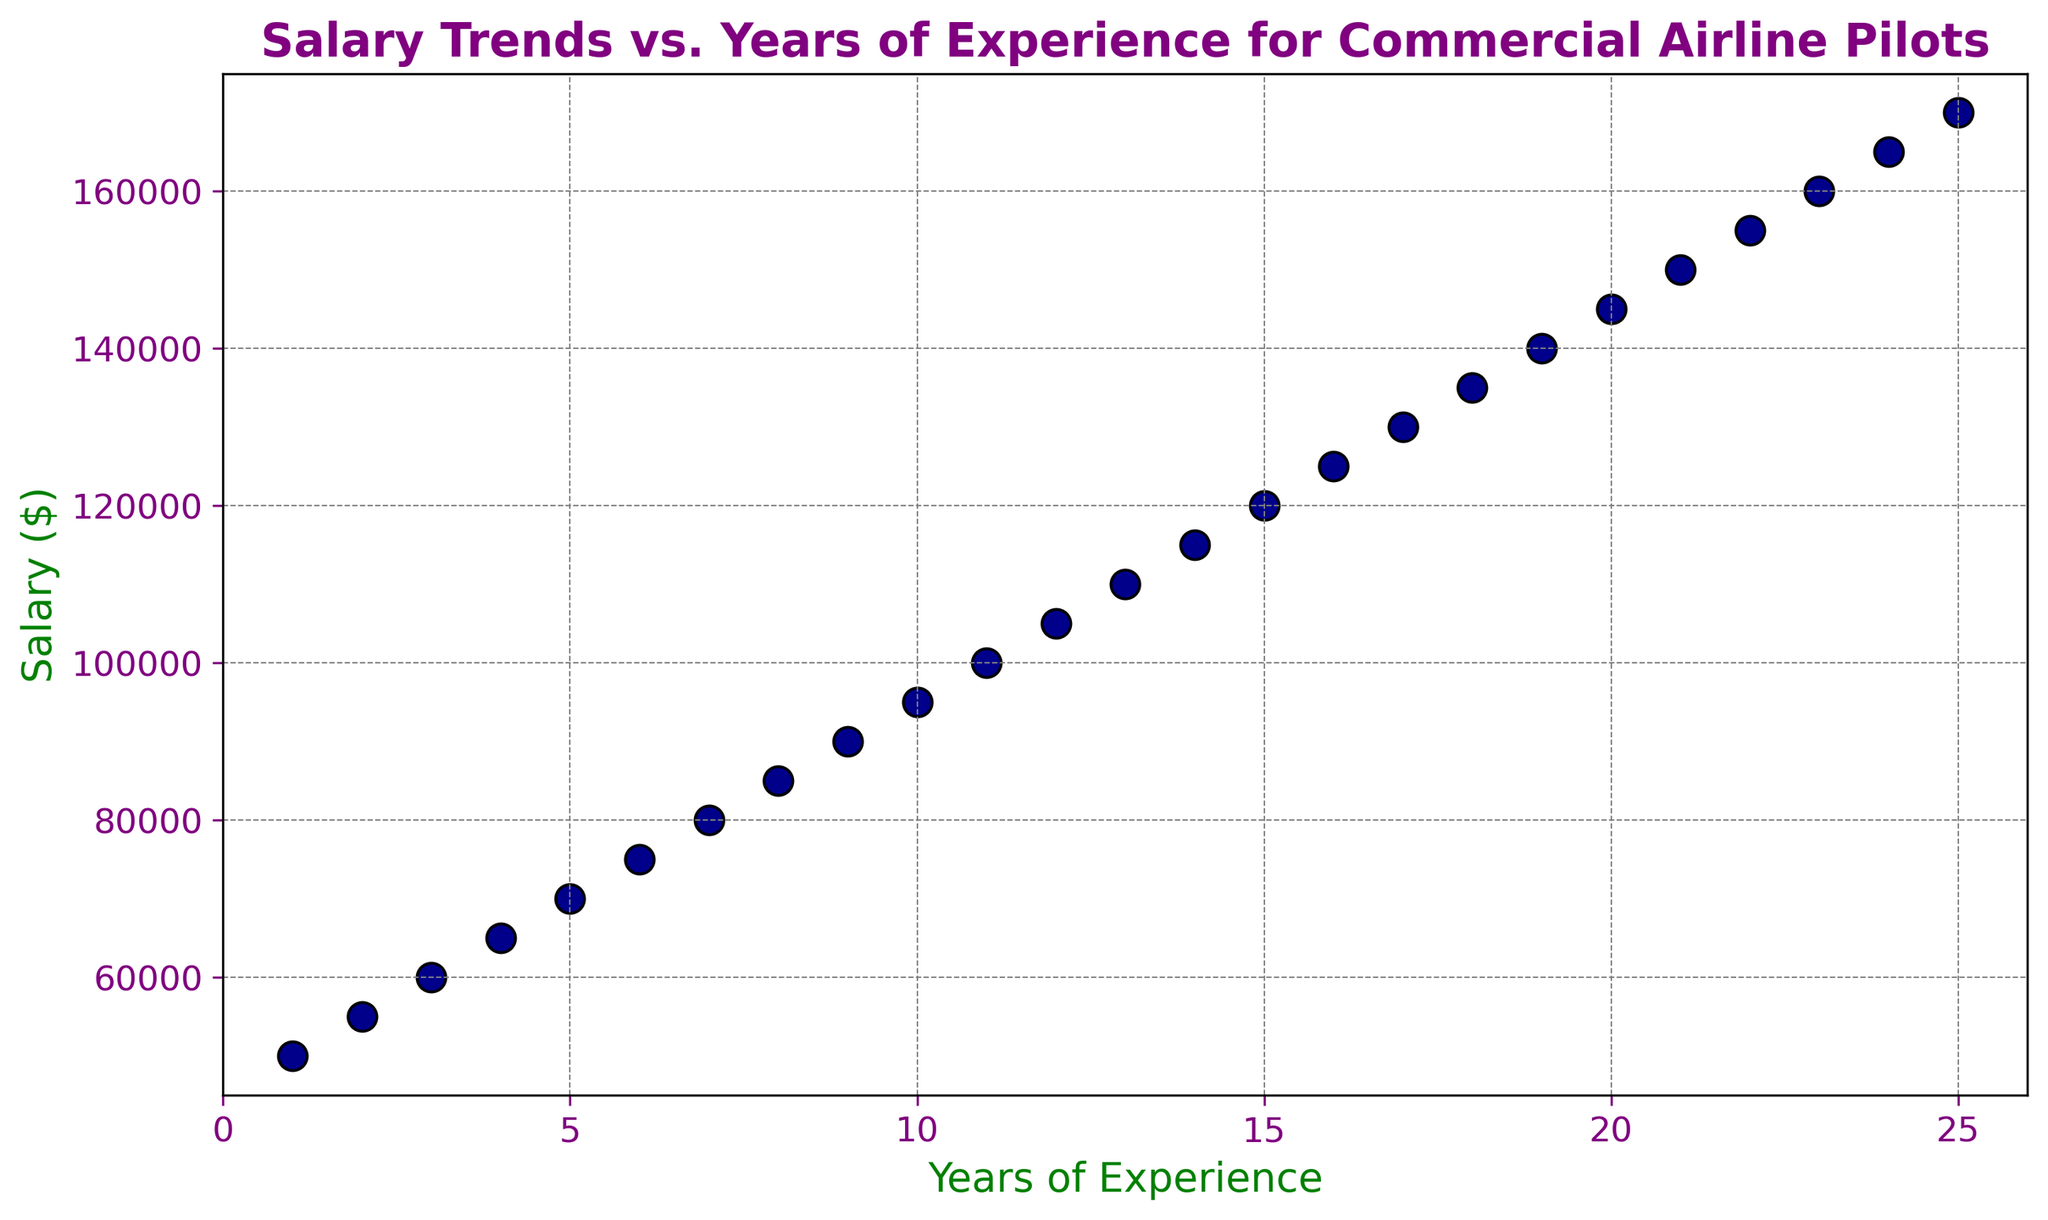What is the salary of a pilot with 10 years of experience? The figure allows us to locate the point corresponding to 10 years of experience on the x-axis and then move vertically to find the salary, which is represented on the y-axis. For 10 years of experience, the salary is $95,000.
Answer: $95,000 How does the salary trend change as years of experience increase, particularly after 10 years? Observing the scatter plot, the salary increases steadily until 10 years of experience, then it continues to increase but at a slower rate. This indicates a change in the slope of the salary trend line after 10 years of experience.
Answer: Slower rate of increase after 10 years Which year of experience marks the first time a pilot's salary reaches six figures? To find this, we look at the y-axis for the salary value of $100,000 and then trace it horizontally to find the corresponding x-axis value. The scatter plot shows that the first time the salary hits six figures is at 11 years of experience.
Answer: 11 years Is the salary increase between 1 and 5 years of experience greater than the increase between 20 and 25 years of experience? To determine this, we calculate the difference in salaries: for 1 to 5 years, the increase is $70,000 - $50,000 = $20,000; for 20 to 25 years, it is $170,000 - $145,000 = $25,000. Comparing these, the increase between 20 and 25 years is greater.
Answer: No At what year of experience does the pilot’s salary reach $145,000? We look for the point on the scatter plot that corresponds to a salary of $145,000 on the y-axis and then find the associated x-axis value, which represents the years of experience. The plot shows that this occurs at 20 years of experience.
Answer: 20 years What is the average salary of pilots between 1 and 5 years of experience? To find the average, sum the salaries at 1, 2, 3, 4, and 5 years: $50,000 + $55,000 + $60,000 + $65,000 + $70,000 = $300,000. Then, divide by the number of years, which is 5. The average salary in this range is $300,000 / 5 = $60,000.
Answer: $60,000 How much more does a pilot with 15 years of experience earn compared to a pilot with 3 years of experience? Finding the salaries for 15 and 3 years from the plot (which are $120,000 and $60,000 respectively), we subtract the two values: $120,000 - $60,000. The difference is $60,000.
Answer: $60,000 What is the color of the markers representing the data points? The visual attribute of color can be observed directly from the scatter plot. The markers for the data points are dark blue.
Answer: Dark blue Is there any noticeable pattern or relationship between years of experience and salary shown in the plot? The scatter plot reveals a positive correlation between years of experience and salary, indicating that as experience increases, so does the salary. This trend is steady with a slight reduction in the rate of increase beyond 10 years.
Answer: Positive correlation 